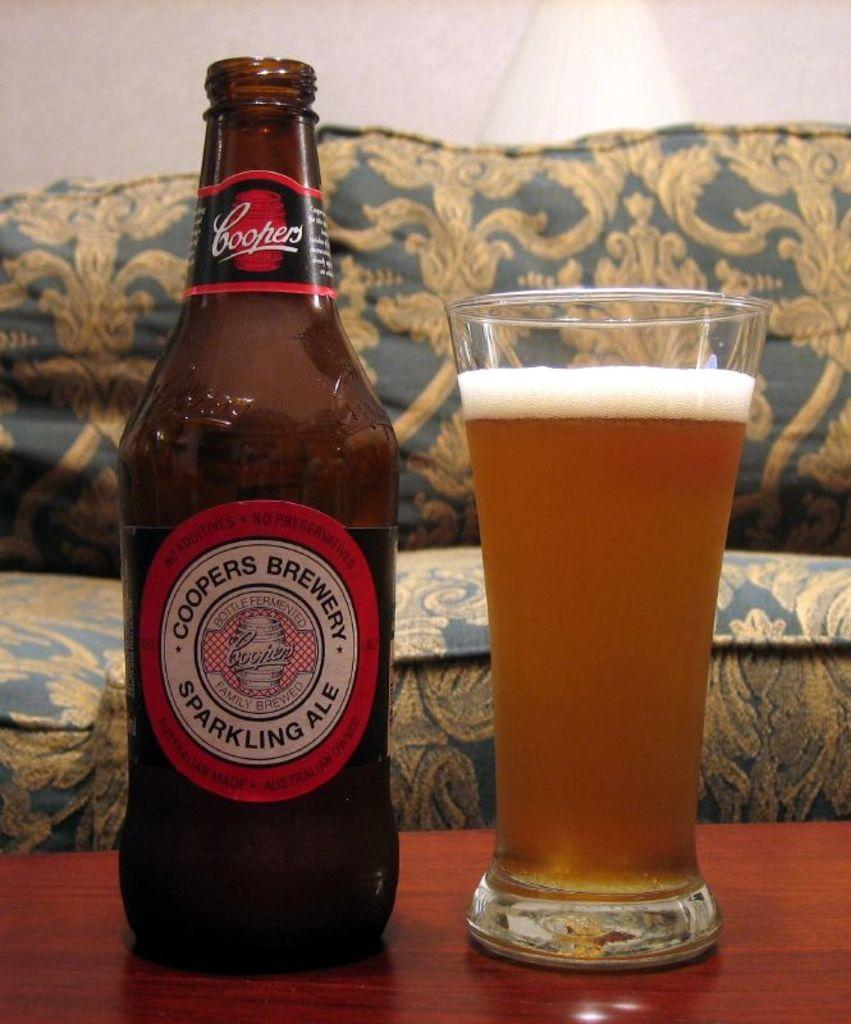<image>
Render a clear and concise summary of the photo. The beer in the glass in Coopers Sparkling Ale. 